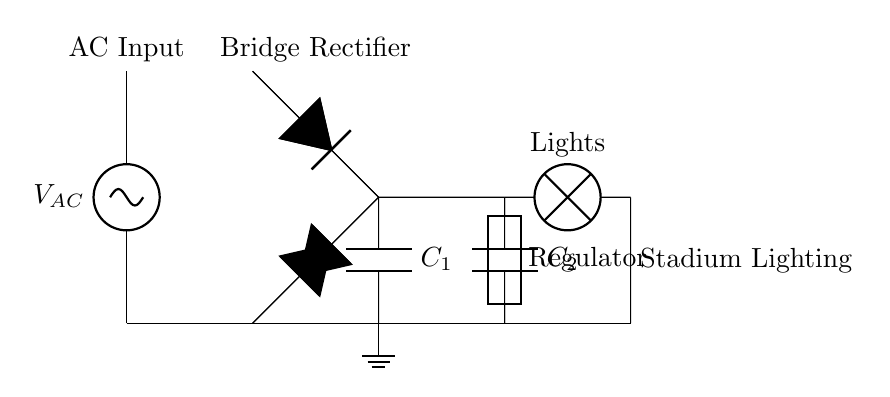What type of rectifier is used in this circuit? The circuit diagram shows a bridge rectifier composed of four diodes arranged in a bridge configuration, which allows for rectification of both halves of the AC waveform.
Answer: Bridge rectifier What is the purpose of capacitor C1? Capacitor C1 is a smoothing capacitor that helps to reduce the ripple voltage in the rectified output, ensuring a more stable DC voltage is provided to the load.
Answer: Smoothing What type of load is connected in this circuit? The load connected in this circuit is the stadium lighting system, which is represented by a lamp in the diagram, clearly indicating the type of application for the generated power.
Answer: Stadium lights What is the function of the voltage regulator in this circuit? The voltage regulator in the circuit ensures that the output voltage remains constant despite variations in the input voltage or the load current, providing a stable supply for the lights.
Answer: Regulation How many diodes are used in the bridge rectifier? There are four diodes used in the bridge rectifier configuration, which work together to convert the AC input into a DC output by allowing current to pass in both directions of the AC cycle.
Answer: Four diodes What does the smoothing capacitor C2 do? Capacitor C2 also acts as a smoothing capacitor by further filtering the output, ensuring a steady DC voltage to the load while reducing any remaining ripple from the rectification process.
Answer: Smoothing 